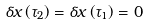Convert formula to latex. <formula><loc_0><loc_0><loc_500><loc_500>\delta x \left ( \tau _ { 2 } \right ) = \delta x \left ( \tau _ { 1 } \right ) = 0</formula> 